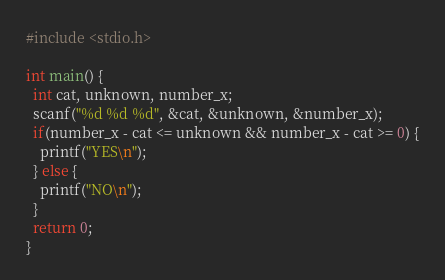Convert code to text. <code><loc_0><loc_0><loc_500><loc_500><_C_>#include <stdio.h>

int main() {
  int cat, unknown, number_x;
  scanf("%d %d %d", &cat, &unknown, &number_x);
  if(number_x - cat <= unknown && number_x - cat >= 0) {
    printf("YES\n");
  } else {
    printf("NO\n");
  }
  return 0;
}
</code> 